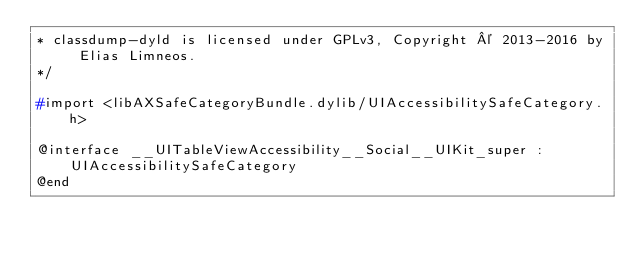<code> <loc_0><loc_0><loc_500><loc_500><_C_>* classdump-dyld is licensed under GPLv3, Copyright © 2013-2016 by Elias Limneos.
*/

#import <libAXSafeCategoryBundle.dylib/UIAccessibilitySafeCategory.h>

@interface __UITableViewAccessibility__Social__UIKit_super : UIAccessibilitySafeCategory
@end

</code> 